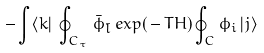<formula> <loc_0><loc_0><loc_500><loc_500>- \int \langle k | \, \oint _ { C _ { \tau } } \, { \bar { \phi } } _ { \bar { l } } \, e x p ( \, - \, T H ) \oint _ { C } \phi _ { i } \, | j \rangle</formula> 